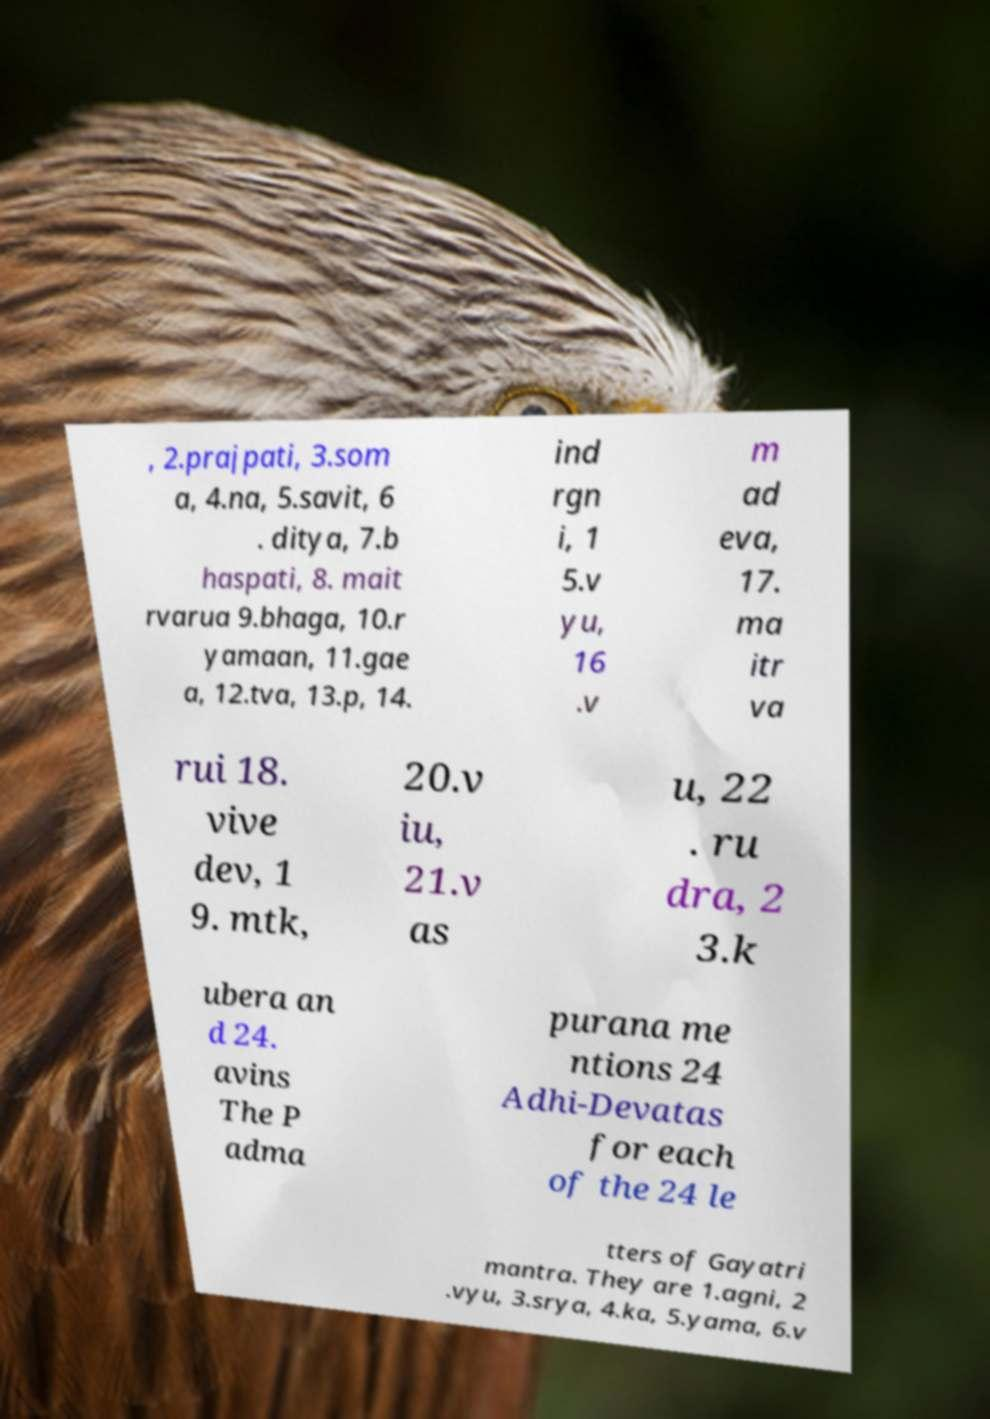Please identify and transcribe the text found in this image. , 2.prajpati, 3.som a, 4.na, 5.savit, 6 . ditya, 7.b haspati, 8. mait rvarua 9.bhaga, 10.r yamaan, 11.gae a, 12.tva, 13.p, 14. ind rgn i, 1 5.v yu, 16 .v m ad eva, 17. ma itr va rui 18. vive dev, 1 9. mtk, 20.v iu, 21.v as u, 22 . ru dra, 2 3.k ubera an d 24. avins The P adma purana me ntions 24 Adhi-Devatas for each of the 24 le tters of Gayatri mantra. They are 1.agni, 2 .vyu, 3.srya, 4.ka, 5.yama, 6.v 